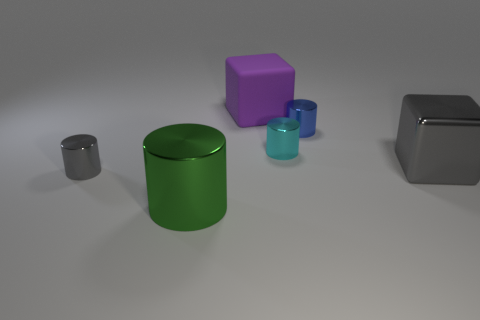Are there any other things that are the same shape as the large gray thing?
Give a very brief answer. Yes. There is a cube that is on the left side of the cyan cylinder; is it the same size as the tiny cyan metal cylinder?
Offer a terse response. No. How many metallic things are large purple things or gray objects?
Provide a short and direct response. 2. How big is the purple rubber thing left of the cyan cylinder?
Ensure brevity in your answer.  Large. Is the shape of the purple matte thing the same as the cyan metal thing?
Provide a short and direct response. No. What number of small objects are cyan things or green cylinders?
Provide a short and direct response. 1. There is a large gray metal cube; are there any gray things left of it?
Give a very brief answer. Yes. Are there an equal number of blue objects on the left side of the green thing and large metallic blocks?
Give a very brief answer. No. The blue metal object that is the same shape as the tiny gray shiny thing is what size?
Make the answer very short. Small. There is a purple object; is its shape the same as the gray metal object that is on the right side of the large purple thing?
Give a very brief answer. Yes. 